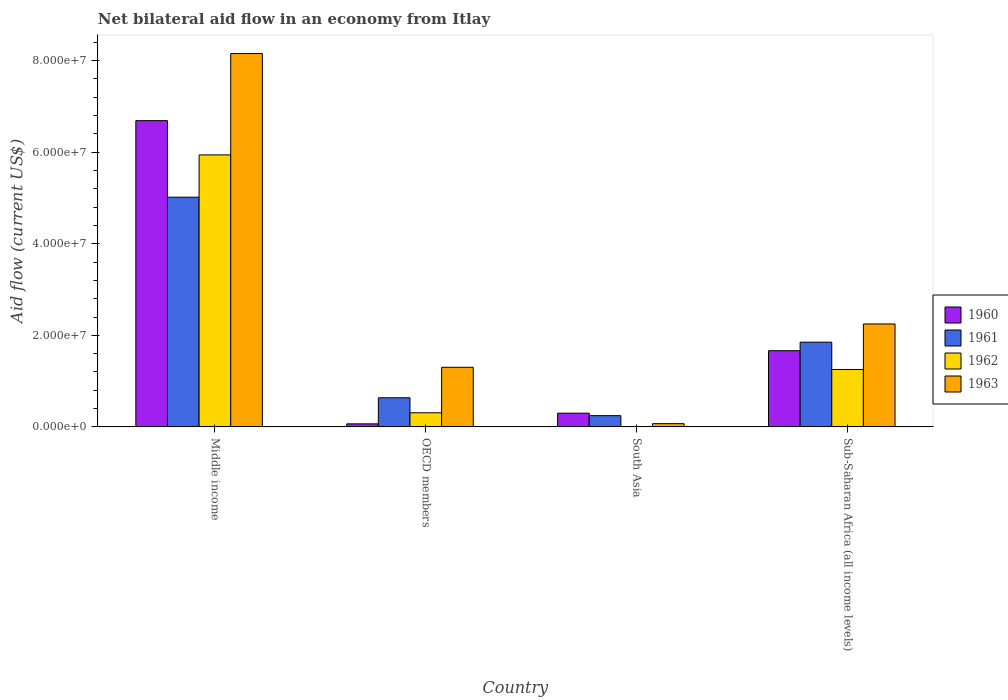How many different coloured bars are there?
Your response must be concise. 4. How many bars are there on the 4th tick from the left?
Your response must be concise. 4. What is the label of the 4th group of bars from the left?
Offer a terse response. Sub-Saharan Africa (all income levels). In how many cases, is the number of bars for a given country not equal to the number of legend labels?
Your answer should be compact. 1. What is the net bilateral aid flow in 1962 in OECD members?
Offer a terse response. 3.08e+06. Across all countries, what is the maximum net bilateral aid flow in 1962?
Your answer should be very brief. 5.94e+07. What is the total net bilateral aid flow in 1961 in the graph?
Offer a very short reply. 7.75e+07. What is the difference between the net bilateral aid flow in 1961 in Middle income and that in OECD members?
Offer a terse response. 4.38e+07. What is the difference between the net bilateral aid flow in 1962 in OECD members and the net bilateral aid flow in 1961 in South Asia?
Your answer should be very brief. 6.30e+05. What is the average net bilateral aid flow in 1961 per country?
Keep it short and to the point. 1.94e+07. What is the difference between the net bilateral aid flow of/in 1963 and net bilateral aid flow of/in 1960 in OECD members?
Your answer should be very brief. 1.24e+07. What is the ratio of the net bilateral aid flow in 1961 in OECD members to that in Sub-Saharan Africa (all income levels)?
Ensure brevity in your answer.  0.34. Is the difference between the net bilateral aid flow in 1963 in Middle income and Sub-Saharan Africa (all income levels) greater than the difference between the net bilateral aid flow in 1960 in Middle income and Sub-Saharan Africa (all income levels)?
Provide a short and direct response. Yes. What is the difference between the highest and the second highest net bilateral aid flow in 1963?
Your response must be concise. 6.85e+07. What is the difference between the highest and the lowest net bilateral aid flow in 1962?
Offer a very short reply. 5.94e+07. Is it the case that in every country, the sum of the net bilateral aid flow in 1963 and net bilateral aid flow in 1962 is greater than the sum of net bilateral aid flow in 1960 and net bilateral aid flow in 1961?
Keep it short and to the point. No. Is it the case that in every country, the sum of the net bilateral aid flow in 1961 and net bilateral aid flow in 1960 is greater than the net bilateral aid flow in 1962?
Your answer should be compact. Yes. How many bars are there?
Ensure brevity in your answer.  15. What is the difference between two consecutive major ticks on the Y-axis?
Make the answer very short. 2.00e+07. Does the graph contain any zero values?
Provide a succinct answer. Yes. How are the legend labels stacked?
Keep it short and to the point. Vertical. What is the title of the graph?
Your answer should be very brief. Net bilateral aid flow in an economy from Itlay. What is the Aid flow (current US$) of 1960 in Middle income?
Provide a short and direct response. 6.69e+07. What is the Aid flow (current US$) of 1961 in Middle income?
Keep it short and to the point. 5.02e+07. What is the Aid flow (current US$) of 1962 in Middle income?
Your answer should be compact. 5.94e+07. What is the Aid flow (current US$) of 1963 in Middle income?
Offer a very short reply. 8.16e+07. What is the Aid flow (current US$) of 1960 in OECD members?
Ensure brevity in your answer.  6.60e+05. What is the Aid flow (current US$) in 1961 in OECD members?
Your answer should be very brief. 6.36e+06. What is the Aid flow (current US$) of 1962 in OECD members?
Offer a terse response. 3.08e+06. What is the Aid flow (current US$) in 1963 in OECD members?
Give a very brief answer. 1.30e+07. What is the Aid flow (current US$) of 1960 in South Asia?
Your response must be concise. 2.99e+06. What is the Aid flow (current US$) of 1961 in South Asia?
Your response must be concise. 2.45e+06. What is the Aid flow (current US$) of 1963 in South Asia?
Offer a terse response. 7.00e+05. What is the Aid flow (current US$) in 1960 in Sub-Saharan Africa (all income levels)?
Ensure brevity in your answer.  1.66e+07. What is the Aid flow (current US$) in 1961 in Sub-Saharan Africa (all income levels)?
Keep it short and to the point. 1.85e+07. What is the Aid flow (current US$) in 1962 in Sub-Saharan Africa (all income levels)?
Provide a short and direct response. 1.25e+07. What is the Aid flow (current US$) of 1963 in Sub-Saharan Africa (all income levels)?
Provide a short and direct response. 2.25e+07. Across all countries, what is the maximum Aid flow (current US$) in 1960?
Make the answer very short. 6.69e+07. Across all countries, what is the maximum Aid flow (current US$) of 1961?
Your answer should be very brief. 5.02e+07. Across all countries, what is the maximum Aid flow (current US$) in 1962?
Your answer should be compact. 5.94e+07. Across all countries, what is the maximum Aid flow (current US$) in 1963?
Your answer should be very brief. 8.16e+07. Across all countries, what is the minimum Aid flow (current US$) in 1960?
Provide a short and direct response. 6.60e+05. Across all countries, what is the minimum Aid flow (current US$) of 1961?
Make the answer very short. 2.45e+06. Across all countries, what is the minimum Aid flow (current US$) of 1962?
Keep it short and to the point. 0. Across all countries, what is the minimum Aid flow (current US$) of 1963?
Ensure brevity in your answer.  7.00e+05. What is the total Aid flow (current US$) of 1960 in the graph?
Your answer should be very brief. 8.72e+07. What is the total Aid flow (current US$) in 1961 in the graph?
Your response must be concise. 7.75e+07. What is the total Aid flow (current US$) in 1962 in the graph?
Your response must be concise. 7.50e+07. What is the total Aid flow (current US$) in 1963 in the graph?
Make the answer very short. 1.18e+08. What is the difference between the Aid flow (current US$) of 1960 in Middle income and that in OECD members?
Ensure brevity in your answer.  6.62e+07. What is the difference between the Aid flow (current US$) of 1961 in Middle income and that in OECD members?
Keep it short and to the point. 4.38e+07. What is the difference between the Aid flow (current US$) of 1962 in Middle income and that in OECD members?
Keep it short and to the point. 5.63e+07. What is the difference between the Aid flow (current US$) of 1963 in Middle income and that in OECD members?
Your answer should be very brief. 6.85e+07. What is the difference between the Aid flow (current US$) of 1960 in Middle income and that in South Asia?
Provide a short and direct response. 6.39e+07. What is the difference between the Aid flow (current US$) in 1961 in Middle income and that in South Asia?
Your response must be concise. 4.77e+07. What is the difference between the Aid flow (current US$) in 1963 in Middle income and that in South Asia?
Make the answer very short. 8.08e+07. What is the difference between the Aid flow (current US$) in 1960 in Middle income and that in Sub-Saharan Africa (all income levels)?
Keep it short and to the point. 5.02e+07. What is the difference between the Aid flow (current US$) of 1961 in Middle income and that in Sub-Saharan Africa (all income levels)?
Provide a succinct answer. 3.17e+07. What is the difference between the Aid flow (current US$) in 1962 in Middle income and that in Sub-Saharan Africa (all income levels)?
Your response must be concise. 4.69e+07. What is the difference between the Aid flow (current US$) in 1963 in Middle income and that in Sub-Saharan Africa (all income levels)?
Give a very brief answer. 5.91e+07. What is the difference between the Aid flow (current US$) of 1960 in OECD members and that in South Asia?
Provide a succinct answer. -2.33e+06. What is the difference between the Aid flow (current US$) in 1961 in OECD members and that in South Asia?
Make the answer very short. 3.91e+06. What is the difference between the Aid flow (current US$) in 1963 in OECD members and that in South Asia?
Your answer should be very brief. 1.23e+07. What is the difference between the Aid flow (current US$) of 1960 in OECD members and that in Sub-Saharan Africa (all income levels)?
Your answer should be very brief. -1.60e+07. What is the difference between the Aid flow (current US$) of 1961 in OECD members and that in Sub-Saharan Africa (all income levels)?
Keep it short and to the point. -1.21e+07. What is the difference between the Aid flow (current US$) in 1962 in OECD members and that in Sub-Saharan Africa (all income levels)?
Your response must be concise. -9.45e+06. What is the difference between the Aid flow (current US$) in 1963 in OECD members and that in Sub-Saharan Africa (all income levels)?
Make the answer very short. -9.46e+06. What is the difference between the Aid flow (current US$) of 1960 in South Asia and that in Sub-Saharan Africa (all income levels)?
Offer a very short reply. -1.36e+07. What is the difference between the Aid flow (current US$) of 1961 in South Asia and that in Sub-Saharan Africa (all income levels)?
Make the answer very short. -1.60e+07. What is the difference between the Aid flow (current US$) of 1963 in South Asia and that in Sub-Saharan Africa (all income levels)?
Your response must be concise. -2.18e+07. What is the difference between the Aid flow (current US$) of 1960 in Middle income and the Aid flow (current US$) of 1961 in OECD members?
Make the answer very short. 6.05e+07. What is the difference between the Aid flow (current US$) of 1960 in Middle income and the Aid flow (current US$) of 1962 in OECD members?
Your answer should be very brief. 6.38e+07. What is the difference between the Aid flow (current US$) in 1960 in Middle income and the Aid flow (current US$) in 1963 in OECD members?
Your answer should be compact. 5.39e+07. What is the difference between the Aid flow (current US$) in 1961 in Middle income and the Aid flow (current US$) in 1962 in OECD members?
Your answer should be very brief. 4.71e+07. What is the difference between the Aid flow (current US$) of 1961 in Middle income and the Aid flow (current US$) of 1963 in OECD members?
Your answer should be very brief. 3.72e+07. What is the difference between the Aid flow (current US$) of 1962 in Middle income and the Aid flow (current US$) of 1963 in OECD members?
Give a very brief answer. 4.64e+07. What is the difference between the Aid flow (current US$) in 1960 in Middle income and the Aid flow (current US$) in 1961 in South Asia?
Your answer should be compact. 6.44e+07. What is the difference between the Aid flow (current US$) in 1960 in Middle income and the Aid flow (current US$) in 1963 in South Asia?
Offer a very short reply. 6.62e+07. What is the difference between the Aid flow (current US$) of 1961 in Middle income and the Aid flow (current US$) of 1963 in South Asia?
Offer a very short reply. 4.95e+07. What is the difference between the Aid flow (current US$) in 1962 in Middle income and the Aid flow (current US$) in 1963 in South Asia?
Ensure brevity in your answer.  5.87e+07. What is the difference between the Aid flow (current US$) in 1960 in Middle income and the Aid flow (current US$) in 1961 in Sub-Saharan Africa (all income levels)?
Offer a terse response. 4.84e+07. What is the difference between the Aid flow (current US$) of 1960 in Middle income and the Aid flow (current US$) of 1962 in Sub-Saharan Africa (all income levels)?
Your answer should be very brief. 5.44e+07. What is the difference between the Aid flow (current US$) in 1960 in Middle income and the Aid flow (current US$) in 1963 in Sub-Saharan Africa (all income levels)?
Offer a very short reply. 4.44e+07. What is the difference between the Aid flow (current US$) in 1961 in Middle income and the Aid flow (current US$) in 1962 in Sub-Saharan Africa (all income levels)?
Provide a short and direct response. 3.76e+07. What is the difference between the Aid flow (current US$) of 1961 in Middle income and the Aid flow (current US$) of 1963 in Sub-Saharan Africa (all income levels)?
Offer a terse response. 2.77e+07. What is the difference between the Aid flow (current US$) of 1962 in Middle income and the Aid flow (current US$) of 1963 in Sub-Saharan Africa (all income levels)?
Offer a very short reply. 3.69e+07. What is the difference between the Aid flow (current US$) of 1960 in OECD members and the Aid flow (current US$) of 1961 in South Asia?
Offer a very short reply. -1.79e+06. What is the difference between the Aid flow (current US$) of 1961 in OECD members and the Aid flow (current US$) of 1963 in South Asia?
Provide a short and direct response. 5.66e+06. What is the difference between the Aid flow (current US$) of 1962 in OECD members and the Aid flow (current US$) of 1963 in South Asia?
Provide a succinct answer. 2.38e+06. What is the difference between the Aid flow (current US$) in 1960 in OECD members and the Aid flow (current US$) in 1961 in Sub-Saharan Africa (all income levels)?
Your answer should be very brief. -1.78e+07. What is the difference between the Aid flow (current US$) of 1960 in OECD members and the Aid flow (current US$) of 1962 in Sub-Saharan Africa (all income levels)?
Ensure brevity in your answer.  -1.19e+07. What is the difference between the Aid flow (current US$) of 1960 in OECD members and the Aid flow (current US$) of 1963 in Sub-Saharan Africa (all income levels)?
Your answer should be compact. -2.18e+07. What is the difference between the Aid flow (current US$) of 1961 in OECD members and the Aid flow (current US$) of 1962 in Sub-Saharan Africa (all income levels)?
Your answer should be compact. -6.17e+06. What is the difference between the Aid flow (current US$) of 1961 in OECD members and the Aid flow (current US$) of 1963 in Sub-Saharan Africa (all income levels)?
Your answer should be very brief. -1.61e+07. What is the difference between the Aid flow (current US$) in 1962 in OECD members and the Aid flow (current US$) in 1963 in Sub-Saharan Africa (all income levels)?
Offer a very short reply. -1.94e+07. What is the difference between the Aid flow (current US$) in 1960 in South Asia and the Aid flow (current US$) in 1961 in Sub-Saharan Africa (all income levels)?
Offer a very short reply. -1.55e+07. What is the difference between the Aid flow (current US$) in 1960 in South Asia and the Aid flow (current US$) in 1962 in Sub-Saharan Africa (all income levels)?
Offer a very short reply. -9.54e+06. What is the difference between the Aid flow (current US$) in 1960 in South Asia and the Aid flow (current US$) in 1963 in Sub-Saharan Africa (all income levels)?
Give a very brief answer. -1.95e+07. What is the difference between the Aid flow (current US$) in 1961 in South Asia and the Aid flow (current US$) in 1962 in Sub-Saharan Africa (all income levels)?
Provide a short and direct response. -1.01e+07. What is the difference between the Aid flow (current US$) of 1961 in South Asia and the Aid flow (current US$) of 1963 in Sub-Saharan Africa (all income levels)?
Ensure brevity in your answer.  -2.00e+07. What is the average Aid flow (current US$) in 1960 per country?
Your response must be concise. 2.18e+07. What is the average Aid flow (current US$) of 1961 per country?
Your answer should be very brief. 1.94e+07. What is the average Aid flow (current US$) in 1962 per country?
Give a very brief answer. 1.88e+07. What is the average Aid flow (current US$) in 1963 per country?
Your answer should be compact. 2.94e+07. What is the difference between the Aid flow (current US$) in 1960 and Aid flow (current US$) in 1961 in Middle income?
Make the answer very short. 1.67e+07. What is the difference between the Aid flow (current US$) in 1960 and Aid flow (current US$) in 1962 in Middle income?
Your answer should be very brief. 7.48e+06. What is the difference between the Aid flow (current US$) of 1960 and Aid flow (current US$) of 1963 in Middle income?
Your answer should be very brief. -1.47e+07. What is the difference between the Aid flow (current US$) in 1961 and Aid flow (current US$) in 1962 in Middle income?
Ensure brevity in your answer.  -9.24e+06. What is the difference between the Aid flow (current US$) of 1961 and Aid flow (current US$) of 1963 in Middle income?
Your answer should be very brief. -3.14e+07. What is the difference between the Aid flow (current US$) in 1962 and Aid flow (current US$) in 1963 in Middle income?
Your answer should be very brief. -2.21e+07. What is the difference between the Aid flow (current US$) of 1960 and Aid flow (current US$) of 1961 in OECD members?
Your response must be concise. -5.70e+06. What is the difference between the Aid flow (current US$) in 1960 and Aid flow (current US$) in 1962 in OECD members?
Offer a very short reply. -2.42e+06. What is the difference between the Aid flow (current US$) of 1960 and Aid flow (current US$) of 1963 in OECD members?
Your answer should be very brief. -1.24e+07. What is the difference between the Aid flow (current US$) in 1961 and Aid flow (current US$) in 1962 in OECD members?
Ensure brevity in your answer.  3.28e+06. What is the difference between the Aid flow (current US$) of 1961 and Aid flow (current US$) of 1963 in OECD members?
Make the answer very short. -6.66e+06. What is the difference between the Aid flow (current US$) in 1962 and Aid flow (current US$) in 1963 in OECD members?
Offer a terse response. -9.94e+06. What is the difference between the Aid flow (current US$) in 1960 and Aid flow (current US$) in 1961 in South Asia?
Your response must be concise. 5.40e+05. What is the difference between the Aid flow (current US$) in 1960 and Aid flow (current US$) in 1963 in South Asia?
Make the answer very short. 2.29e+06. What is the difference between the Aid flow (current US$) in 1961 and Aid flow (current US$) in 1963 in South Asia?
Provide a short and direct response. 1.75e+06. What is the difference between the Aid flow (current US$) of 1960 and Aid flow (current US$) of 1961 in Sub-Saharan Africa (all income levels)?
Keep it short and to the point. -1.86e+06. What is the difference between the Aid flow (current US$) in 1960 and Aid flow (current US$) in 1962 in Sub-Saharan Africa (all income levels)?
Ensure brevity in your answer.  4.11e+06. What is the difference between the Aid flow (current US$) in 1960 and Aid flow (current US$) in 1963 in Sub-Saharan Africa (all income levels)?
Make the answer very short. -5.84e+06. What is the difference between the Aid flow (current US$) in 1961 and Aid flow (current US$) in 1962 in Sub-Saharan Africa (all income levels)?
Provide a short and direct response. 5.97e+06. What is the difference between the Aid flow (current US$) of 1961 and Aid flow (current US$) of 1963 in Sub-Saharan Africa (all income levels)?
Provide a short and direct response. -3.98e+06. What is the difference between the Aid flow (current US$) in 1962 and Aid flow (current US$) in 1963 in Sub-Saharan Africa (all income levels)?
Provide a short and direct response. -9.95e+06. What is the ratio of the Aid flow (current US$) of 1960 in Middle income to that in OECD members?
Give a very brief answer. 101.35. What is the ratio of the Aid flow (current US$) in 1961 in Middle income to that in OECD members?
Ensure brevity in your answer.  7.89. What is the ratio of the Aid flow (current US$) of 1962 in Middle income to that in OECD members?
Your response must be concise. 19.29. What is the ratio of the Aid flow (current US$) of 1963 in Middle income to that in OECD members?
Make the answer very short. 6.26. What is the ratio of the Aid flow (current US$) in 1960 in Middle income to that in South Asia?
Give a very brief answer. 22.37. What is the ratio of the Aid flow (current US$) in 1961 in Middle income to that in South Asia?
Provide a short and direct response. 20.48. What is the ratio of the Aid flow (current US$) in 1963 in Middle income to that in South Asia?
Provide a succinct answer. 116.5. What is the ratio of the Aid flow (current US$) in 1960 in Middle income to that in Sub-Saharan Africa (all income levels)?
Provide a short and direct response. 4.02. What is the ratio of the Aid flow (current US$) of 1961 in Middle income to that in Sub-Saharan Africa (all income levels)?
Offer a terse response. 2.71. What is the ratio of the Aid flow (current US$) of 1962 in Middle income to that in Sub-Saharan Africa (all income levels)?
Keep it short and to the point. 4.74. What is the ratio of the Aid flow (current US$) in 1963 in Middle income to that in Sub-Saharan Africa (all income levels)?
Your answer should be compact. 3.63. What is the ratio of the Aid flow (current US$) of 1960 in OECD members to that in South Asia?
Provide a succinct answer. 0.22. What is the ratio of the Aid flow (current US$) in 1961 in OECD members to that in South Asia?
Your answer should be very brief. 2.6. What is the ratio of the Aid flow (current US$) in 1963 in OECD members to that in South Asia?
Provide a short and direct response. 18.6. What is the ratio of the Aid flow (current US$) in 1960 in OECD members to that in Sub-Saharan Africa (all income levels)?
Give a very brief answer. 0.04. What is the ratio of the Aid flow (current US$) in 1961 in OECD members to that in Sub-Saharan Africa (all income levels)?
Provide a short and direct response. 0.34. What is the ratio of the Aid flow (current US$) of 1962 in OECD members to that in Sub-Saharan Africa (all income levels)?
Provide a short and direct response. 0.25. What is the ratio of the Aid flow (current US$) of 1963 in OECD members to that in Sub-Saharan Africa (all income levels)?
Offer a terse response. 0.58. What is the ratio of the Aid flow (current US$) in 1960 in South Asia to that in Sub-Saharan Africa (all income levels)?
Offer a very short reply. 0.18. What is the ratio of the Aid flow (current US$) in 1961 in South Asia to that in Sub-Saharan Africa (all income levels)?
Keep it short and to the point. 0.13. What is the ratio of the Aid flow (current US$) in 1963 in South Asia to that in Sub-Saharan Africa (all income levels)?
Offer a terse response. 0.03. What is the difference between the highest and the second highest Aid flow (current US$) of 1960?
Make the answer very short. 5.02e+07. What is the difference between the highest and the second highest Aid flow (current US$) of 1961?
Offer a terse response. 3.17e+07. What is the difference between the highest and the second highest Aid flow (current US$) of 1962?
Offer a very short reply. 4.69e+07. What is the difference between the highest and the second highest Aid flow (current US$) in 1963?
Your answer should be compact. 5.91e+07. What is the difference between the highest and the lowest Aid flow (current US$) in 1960?
Offer a terse response. 6.62e+07. What is the difference between the highest and the lowest Aid flow (current US$) of 1961?
Your answer should be compact. 4.77e+07. What is the difference between the highest and the lowest Aid flow (current US$) in 1962?
Make the answer very short. 5.94e+07. What is the difference between the highest and the lowest Aid flow (current US$) in 1963?
Your answer should be very brief. 8.08e+07. 